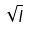<formula> <loc_0><loc_0><loc_500><loc_500>\sqrt { I }</formula> 